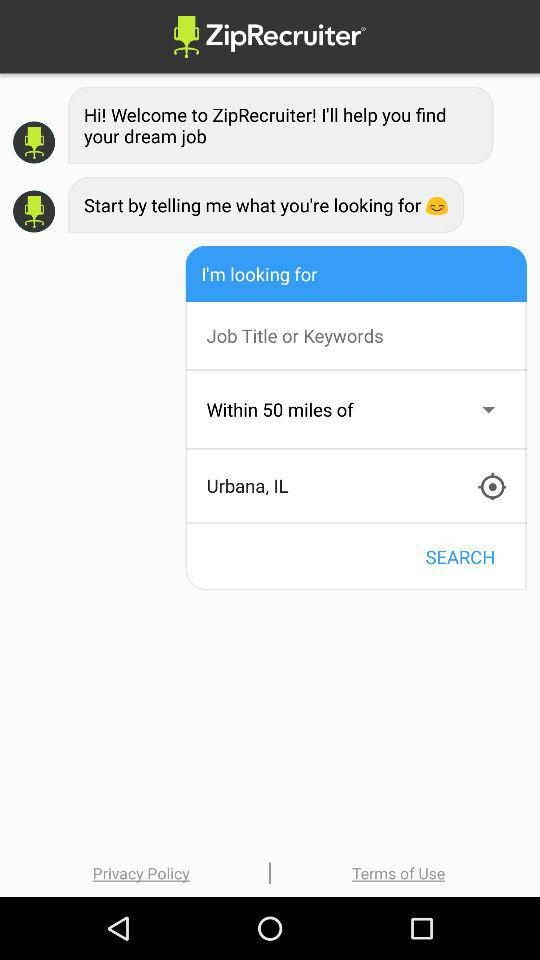What is the mentioned location? The mentioned location is Urbana, IL. 